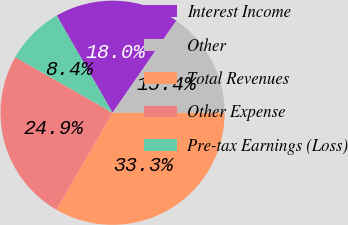Convert chart to OTSL. <chart><loc_0><loc_0><loc_500><loc_500><pie_chart><fcel>Interest Income<fcel>Other<fcel>Total Revenues<fcel>Other Expense<fcel>Pre-tax Earnings (Loss)<nl><fcel>17.95%<fcel>15.38%<fcel>33.33%<fcel>24.9%<fcel>8.43%<nl></chart> 